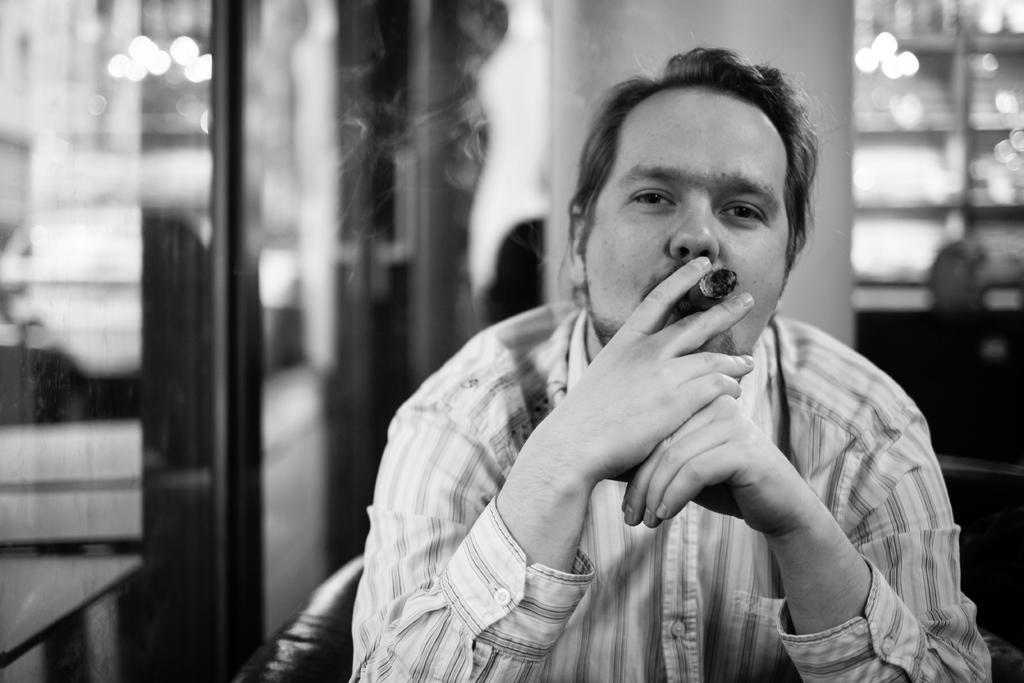Can you describe this image briefly? In the image in the center, we can see one person sitting on the chair and he is holding a cigarette. In the background there is a wall, glass, table and a few other objects. 